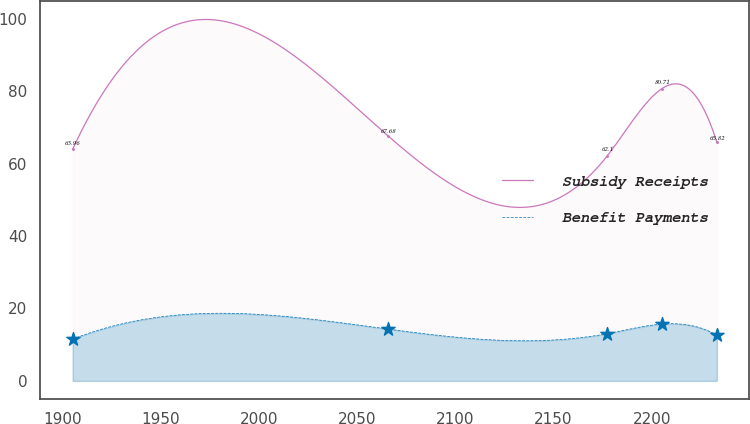Convert chart to OTSL. <chart><loc_0><loc_0><loc_500><loc_500><line_chart><ecel><fcel>Subsidy Receipts<fcel>Benefit Payments<nl><fcel>1905.15<fcel>63.96<fcel>11.52<nl><fcel>2065.7<fcel>67.68<fcel>14.31<nl><fcel>2177.36<fcel>62.1<fcel>13.04<nl><fcel>2205.3<fcel>80.71<fcel>15.68<nl><fcel>2233.24<fcel>65.82<fcel>12.62<nl></chart> 